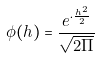<formula> <loc_0><loc_0><loc_500><loc_500>\phi ( h ) = \frac { e ^ { \cdot \frac { h ^ { 2 } } { 2 } } } { \sqrt { 2 \Pi } }</formula> 